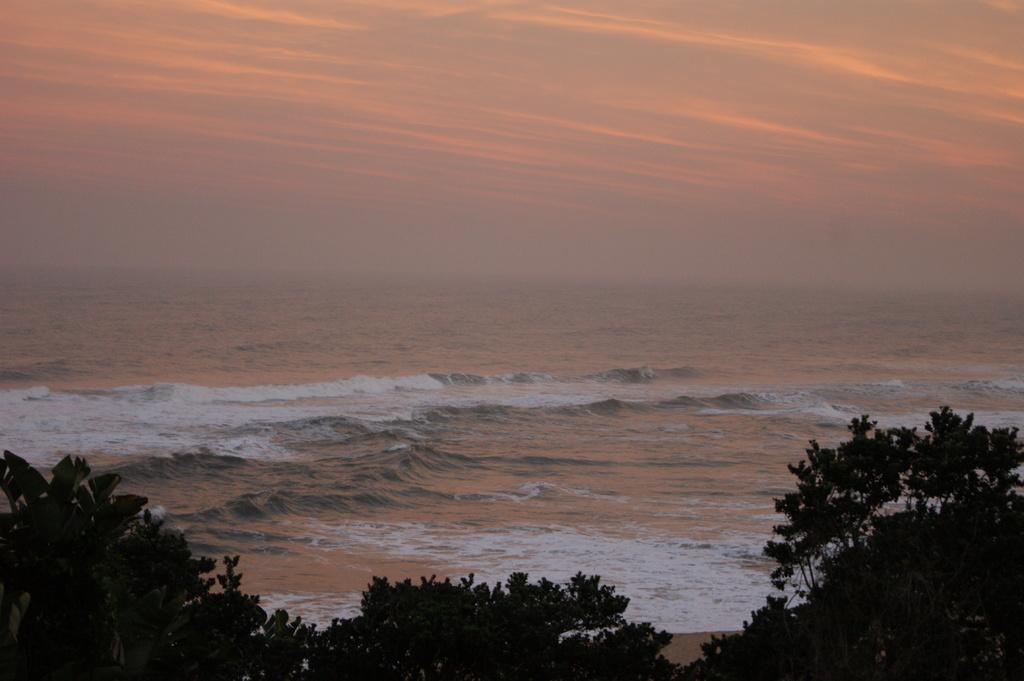What is visible in the image that is not solid? Water is visible in the image and is not solid. What type of vegetation can be seen in the image? Trees are present in the image. What is visible in the background of the image? The sky is visible in the image. What can be seen in the sky in the image? Clouds are present in the sky. What type of paste is being used to hold the trees together in the image? There is no paste present in the image, and the trees are not held together. 